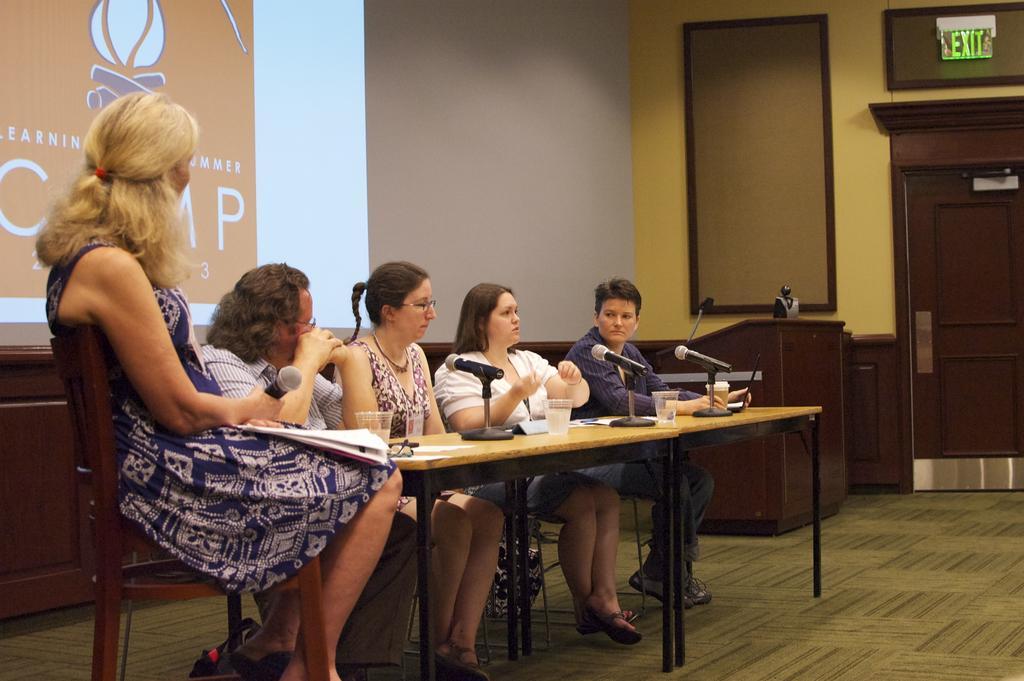Could you give a brief overview of what you see in this image? In the image there are five people two men and three women. The white color shirt woman is talking and remaining people are listening to her. In background there is a screen in which it is written something. On right side there is a wall,podium,frame,door. 